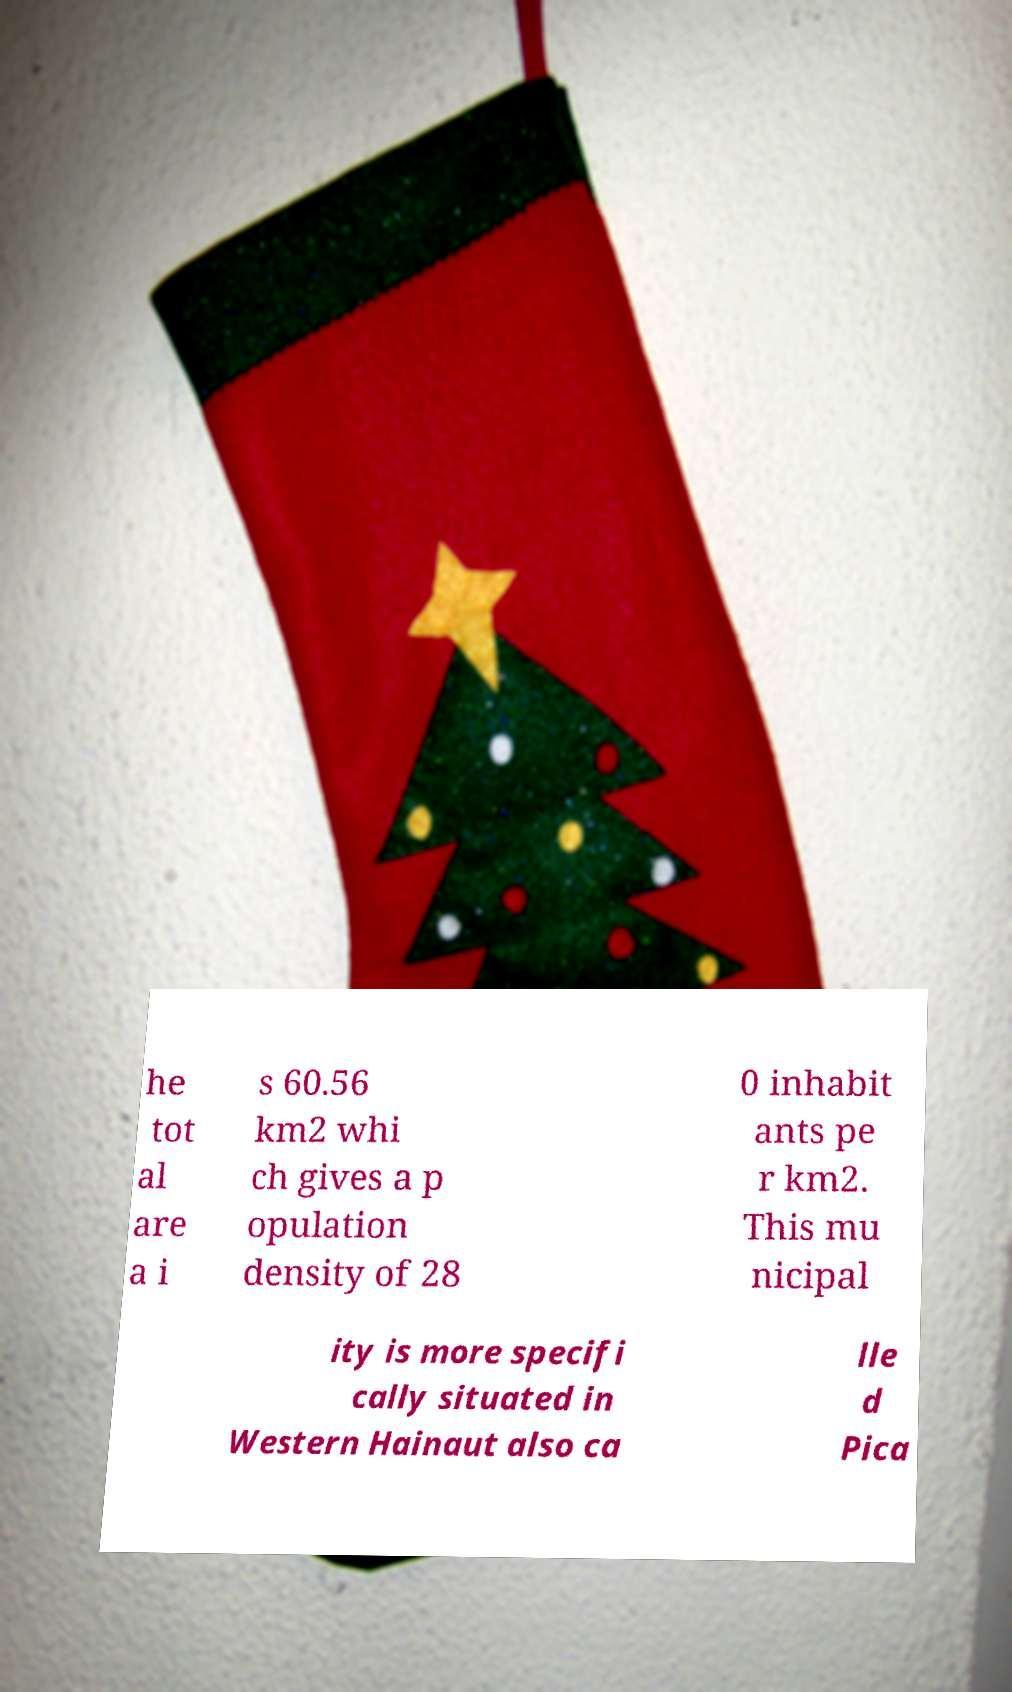I need the written content from this picture converted into text. Can you do that? he tot al are a i s 60.56 km2 whi ch gives a p opulation density of 28 0 inhabit ants pe r km2. This mu nicipal ity is more specifi cally situated in Western Hainaut also ca lle d Pica 